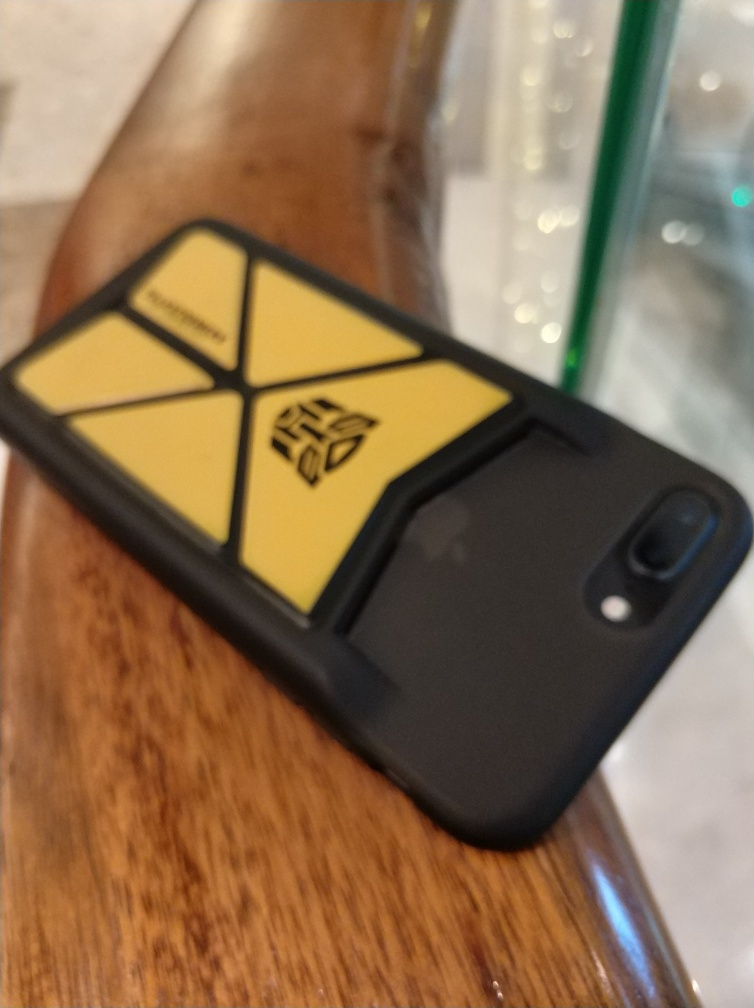How would you describe the composition of this image? The image features an out-of-focus smartphone lying on a wooden surface, angled slightly away from the viewer. The phone has a black case with a distinctive yellow emblem in a triangular design. The emblem is in sharp contrast to the case's dark color, drawing the viewer's eye. The blurred background suggests this photo was taken in a casual, everyday setting, likely a candid shot rather than a professional one. 